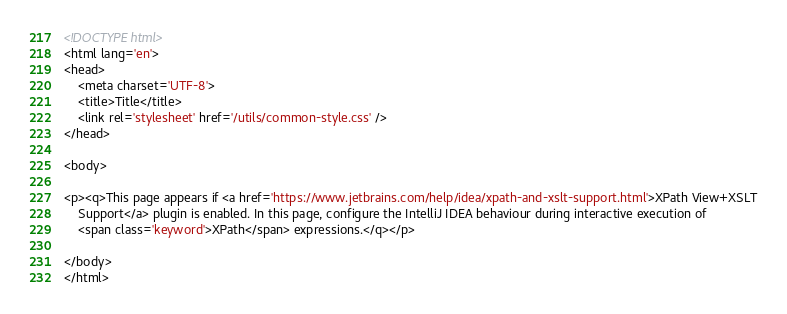Convert code to text. <code><loc_0><loc_0><loc_500><loc_500><_HTML_><!DOCTYPE html>
<html lang='en'>
<head>
	<meta charset='UTF-8'>
	<title>Title</title>
	<link rel='stylesheet' href='/utils/common-style.css' />
</head>

<body>

<p><q>This page appears if <a href='https://www.jetbrains.com/help/idea/xpath-and-xslt-support.html'>XPath View+XSLT
	Support</a> plugin is enabled. In this page, configure the IntelliJ IDEA behaviour during interactive execution of
	<span class='keyword'>XPath</span> expressions.</q></p>

</body>
</html>
</code> 